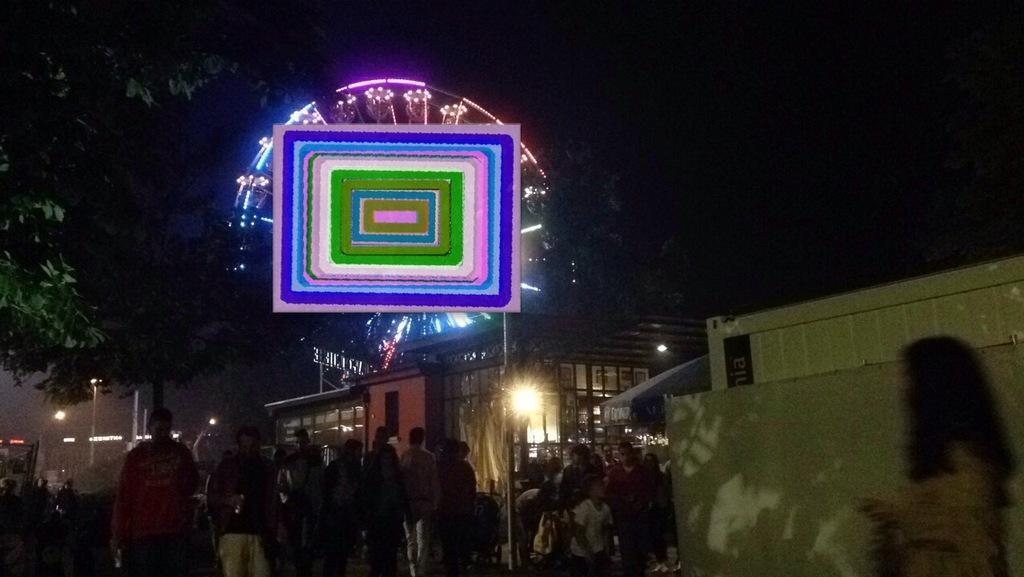What type of structures can be seen in the image? There are buildings and stalls in the image. What are the people in the image doing? There are people standing and walking in the image. What objects can be seen in the image that are used for support or guidance? There are poles in the image. What type of vegetation is present in the image? There are trees in the image. What type of transportation is visible in the image? There is a joint wheel in the image. What is the color of the background in the image? The background of the image is dark. What sound can be heard coming from the zipper in the image? There is no zipper present in the image, so no sound can be heard from it. What is the afterthought of the people in the image? The image does not provide information about the thoughts or feelings of the people, so it is impossible to determine their afterthought. 